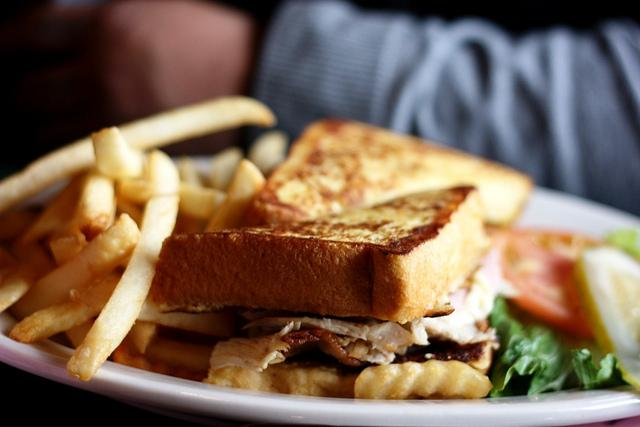What commonly goes on the long light yellow food here? Please explain your reasoning. ketchup. The food is french fries and many people like to dip them in ketchup. 